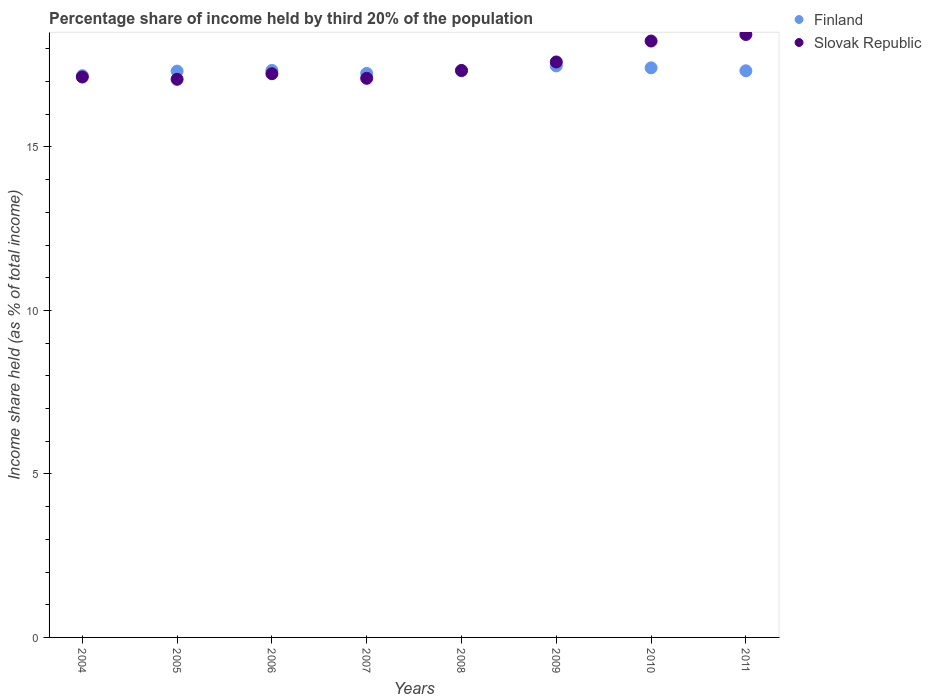Is the number of dotlines equal to the number of legend labels?
Your answer should be very brief. Yes. What is the share of income held by third 20% of the population in Slovak Republic in 2011?
Give a very brief answer. 18.44. Across all years, what is the maximum share of income held by third 20% of the population in Slovak Republic?
Offer a terse response. 18.44. Across all years, what is the minimum share of income held by third 20% of the population in Slovak Republic?
Your answer should be very brief. 17.07. In which year was the share of income held by third 20% of the population in Slovak Republic maximum?
Provide a short and direct response. 2011. What is the total share of income held by third 20% of the population in Finland in the graph?
Give a very brief answer. 138.65. What is the difference between the share of income held by third 20% of the population in Finland in 2005 and that in 2006?
Your answer should be very brief. -0.02. What is the difference between the share of income held by third 20% of the population in Finland in 2011 and the share of income held by third 20% of the population in Slovak Republic in 2007?
Offer a terse response. 0.23. What is the average share of income held by third 20% of the population in Finland per year?
Ensure brevity in your answer.  17.33. In the year 2009, what is the difference between the share of income held by third 20% of the population in Finland and share of income held by third 20% of the population in Slovak Republic?
Provide a short and direct response. -0.12. What is the ratio of the share of income held by third 20% of the population in Finland in 2008 to that in 2009?
Offer a very short reply. 0.99. Is the share of income held by third 20% of the population in Slovak Republic in 2007 less than that in 2010?
Your response must be concise. Yes. Is the difference between the share of income held by third 20% of the population in Finland in 2005 and 2009 greater than the difference between the share of income held by third 20% of the population in Slovak Republic in 2005 and 2009?
Give a very brief answer. Yes. What is the difference between the highest and the second highest share of income held by third 20% of the population in Slovak Republic?
Offer a very short reply. 0.2. What is the difference between the highest and the lowest share of income held by third 20% of the population in Slovak Republic?
Give a very brief answer. 1.37. In how many years, is the share of income held by third 20% of the population in Slovak Republic greater than the average share of income held by third 20% of the population in Slovak Republic taken over all years?
Keep it short and to the point. 3. Is the sum of the share of income held by third 20% of the population in Finland in 2004 and 2006 greater than the maximum share of income held by third 20% of the population in Slovak Republic across all years?
Make the answer very short. Yes. Does the share of income held by third 20% of the population in Slovak Republic monotonically increase over the years?
Keep it short and to the point. No. Is the share of income held by third 20% of the population in Slovak Republic strictly greater than the share of income held by third 20% of the population in Finland over the years?
Offer a very short reply. No. How many years are there in the graph?
Ensure brevity in your answer.  8. Are the values on the major ticks of Y-axis written in scientific E-notation?
Offer a very short reply. No. Does the graph contain grids?
Your answer should be compact. No. How many legend labels are there?
Your answer should be compact. 2. How are the legend labels stacked?
Give a very brief answer. Vertical. What is the title of the graph?
Your response must be concise. Percentage share of income held by third 20% of the population. Does "Sierra Leone" appear as one of the legend labels in the graph?
Keep it short and to the point. No. What is the label or title of the X-axis?
Give a very brief answer. Years. What is the label or title of the Y-axis?
Make the answer very short. Income share held (as % of total income). What is the Income share held (as % of total income) of Finland in 2004?
Offer a very short reply. 17.18. What is the Income share held (as % of total income) in Slovak Republic in 2004?
Give a very brief answer. 17.14. What is the Income share held (as % of total income) of Finland in 2005?
Offer a terse response. 17.32. What is the Income share held (as % of total income) in Slovak Republic in 2005?
Offer a very short reply. 17.07. What is the Income share held (as % of total income) in Finland in 2006?
Keep it short and to the point. 17.34. What is the Income share held (as % of total income) in Slovak Republic in 2006?
Ensure brevity in your answer.  17.24. What is the Income share held (as % of total income) in Finland in 2007?
Provide a short and direct response. 17.25. What is the Income share held (as % of total income) of Slovak Republic in 2007?
Your answer should be very brief. 17.1. What is the Income share held (as % of total income) of Finland in 2008?
Your answer should be compact. 17.33. What is the Income share held (as % of total income) of Slovak Republic in 2008?
Your response must be concise. 17.34. What is the Income share held (as % of total income) of Finland in 2009?
Ensure brevity in your answer.  17.48. What is the Income share held (as % of total income) of Slovak Republic in 2009?
Your answer should be very brief. 17.6. What is the Income share held (as % of total income) in Finland in 2010?
Give a very brief answer. 17.42. What is the Income share held (as % of total income) of Slovak Republic in 2010?
Your response must be concise. 18.24. What is the Income share held (as % of total income) of Finland in 2011?
Make the answer very short. 17.33. What is the Income share held (as % of total income) in Slovak Republic in 2011?
Provide a short and direct response. 18.44. Across all years, what is the maximum Income share held (as % of total income) of Finland?
Provide a succinct answer. 17.48. Across all years, what is the maximum Income share held (as % of total income) of Slovak Republic?
Your answer should be very brief. 18.44. Across all years, what is the minimum Income share held (as % of total income) in Finland?
Keep it short and to the point. 17.18. Across all years, what is the minimum Income share held (as % of total income) in Slovak Republic?
Ensure brevity in your answer.  17.07. What is the total Income share held (as % of total income) of Finland in the graph?
Your answer should be very brief. 138.65. What is the total Income share held (as % of total income) in Slovak Republic in the graph?
Make the answer very short. 140.17. What is the difference between the Income share held (as % of total income) in Finland in 2004 and that in 2005?
Ensure brevity in your answer.  -0.14. What is the difference between the Income share held (as % of total income) in Slovak Republic in 2004 and that in 2005?
Ensure brevity in your answer.  0.07. What is the difference between the Income share held (as % of total income) of Finland in 2004 and that in 2006?
Offer a very short reply. -0.16. What is the difference between the Income share held (as % of total income) in Finland in 2004 and that in 2007?
Provide a short and direct response. -0.07. What is the difference between the Income share held (as % of total income) in Slovak Republic in 2004 and that in 2007?
Your answer should be compact. 0.04. What is the difference between the Income share held (as % of total income) in Slovak Republic in 2004 and that in 2009?
Provide a succinct answer. -0.46. What is the difference between the Income share held (as % of total income) in Finland in 2004 and that in 2010?
Make the answer very short. -0.24. What is the difference between the Income share held (as % of total income) of Finland in 2004 and that in 2011?
Provide a succinct answer. -0.15. What is the difference between the Income share held (as % of total income) in Slovak Republic in 2004 and that in 2011?
Your answer should be very brief. -1.3. What is the difference between the Income share held (as % of total income) of Finland in 2005 and that in 2006?
Your answer should be compact. -0.02. What is the difference between the Income share held (as % of total income) of Slovak Republic in 2005 and that in 2006?
Your answer should be very brief. -0.17. What is the difference between the Income share held (as % of total income) of Finland in 2005 and that in 2007?
Your response must be concise. 0.07. What is the difference between the Income share held (as % of total income) of Slovak Republic in 2005 and that in 2007?
Keep it short and to the point. -0.03. What is the difference between the Income share held (as % of total income) in Finland in 2005 and that in 2008?
Offer a very short reply. -0.01. What is the difference between the Income share held (as % of total income) in Slovak Republic in 2005 and that in 2008?
Your response must be concise. -0.27. What is the difference between the Income share held (as % of total income) of Finland in 2005 and that in 2009?
Ensure brevity in your answer.  -0.16. What is the difference between the Income share held (as % of total income) of Slovak Republic in 2005 and that in 2009?
Provide a succinct answer. -0.53. What is the difference between the Income share held (as % of total income) of Finland in 2005 and that in 2010?
Offer a very short reply. -0.1. What is the difference between the Income share held (as % of total income) of Slovak Republic in 2005 and that in 2010?
Your answer should be compact. -1.17. What is the difference between the Income share held (as % of total income) of Finland in 2005 and that in 2011?
Your answer should be very brief. -0.01. What is the difference between the Income share held (as % of total income) in Slovak Republic in 2005 and that in 2011?
Make the answer very short. -1.37. What is the difference between the Income share held (as % of total income) in Finland in 2006 and that in 2007?
Your answer should be compact. 0.09. What is the difference between the Income share held (as % of total income) of Slovak Republic in 2006 and that in 2007?
Your response must be concise. 0.14. What is the difference between the Income share held (as % of total income) of Finland in 2006 and that in 2009?
Provide a short and direct response. -0.14. What is the difference between the Income share held (as % of total income) of Slovak Republic in 2006 and that in 2009?
Ensure brevity in your answer.  -0.36. What is the difference between the Income share held (as % of total income) of Finland in 2006 and that in 2010?
Make the answer very short. -0.08. What is the difference between the Income share held (as % of total income) of Slovak Republic in 2006 and that in 2010?
Provide a succinct answer. -1. What is the difference between the Income share held (as % of total income) of Finland in 2006 and that in 2011?
Keep it short and to the point. 0.01. What is the difference between the Income share held (as % of total income) in Slovak Republic in 2006 and that in 2011?
Give a very brief answer. -1.2. What is the difference between the Income share held (as % of total income) of Finland in 2007 and that in 2008?
Your answer should be very brief. -0.08. What is the difference between the Income share held (as % of total income) of Slovak Republic in 2007 and that in 2008?
Your response must be concise. -0.24. What is the difference between the Income share held (as % of total income) in Finland in 2007 and that in 2009?
Provide a short and direct response. -0.23. What is the difference between the Income share held (as % of total income) of Slovak Republic in 2007 and that in 2009?
Make the answer very short. -0.5. What is the difference between the Income share held (as % of total income) of Finland in 2007 and that in 2010?
Make the answer very short. -0.17. What is the difference between the Income share held (as % of total income) in Slovak Republic in 2007 and that in 2010?
Make the answer very short. -1.14. What is the difference between the Income share held (as % of total income) of Finland in 2007 and that in 2011?
Your answer should be compact. -0.08. What is the difference between the Income share held (as % of total income) of Slovak Republic in 2007 and that in 2011?
Keep it short and to the point. -1.34. What is the difference between the Income share held (as % of total income) of Finland in 2008 and that in 2009?
Provide a succinct answer. -0.15. What is the difference between the Income share held (as % of total income) in Slovak Republic in 2008 and that in 2009?
Provide a succinct answer. -0.26. What is the difference between the Income share held (as % of total income) of Finland in 2008 and that in 2010?
Offer a terse response. -0.09. What is the difference between the Income share held (as % of total income) of Finland in 2008 and that in 2011?
Provide a succinct answer. 0. What is the difference between the Income share held (as % of total income) of Slovak Republic in 2008 and that in 2011?
Offer a very short reply. -1.1. What is the difference between the Income share held (as % of total income) of Slovak Republic in 2009 and that in 2010?
Offer a terse response. -0.64. What is the difference between the Income share held (as % of total income) in Slovak Republic in 2009 and that in 2011?
Your response must be concise. -0.84. What is the difference between the Income share held (as % of total income) of Finland in 2010 and that in 2011?
Give a very brief answer. 0.09. What is the difference between the Income share held (as % of total income) in Finland in 2004 and the Income share held (as % of total income) in Slovak Republic in 2005?
Give a very brief answer. 0.11. What is the difference between the Income share held (as % of total income) of Finland in 2004 and the Income share held (as % of total income) of Slovak Republic in 2006?
Provide a short and direct response. -0.06. What is the difference between the Income share held (as % of total income) of Finland in 2004 and the Income share held (as % of total income) of Slovak Republic in 2007?
Your answer should be very brief. 0.08. What is the difference between the Income share held (as % of total income) of Finland in 2004 and the Income share held (as % of total income) of Slovak Republic in 2008?
Keep it short and to the point. -0.16. What is the difference between the Income share held (as % of total income) of Finland in 2004 and the Income share held (as % of total income) of Slovak Republic in 2009?
Offer a very short reply. -0.42. What is the difference between the Income share held (as % of total income) of Finland in 2004 and the Income share held (as % of total income) of Slovak Republic in 2010?
Keep it short and to the point. -1.06. What is the difference between the Income share held (as % of total income) in Finland in 2004 and the Income share held (as % of total income) in Slovak Republic in 2011?
Make the answer very short. -1.26. What is the difference between the Income share held (as % of total income) in Finland in 2005 and the Income share held (as % of total income) in Slovak Republic in 2006?
Your answer should be very brief. 0.08. What is the difference between the Income share held (as % of total income) in Finland in 2005 and the Income share held (as % of total income) in Slovak Republic in 2007?
Provide a short and direct response. 0.22. What is the difference between the Income share held (as % of total income) in Finland in 2005 and the Income share held (as % of total income) in Slovak Republic in 2008?
Give a very brief answer. -0.02. What is the difference between the Income share held (as % of total income) in Finland in 2005 and the Income share held (as % of total income) in Slovak Republic in 2009?
Your answer should be compact. -0.28. What is the difference between the Income share held (as % of total income) of Finland in 2005 and the Income share held (as % of total income) of Slovak Republic in 2010?
Make the answer very short. -0.92. What is the difference between the Income share held (as % of total income) of Finland in 2005 and the Income share held (as % of total income) of Slovak Republic in 2011?
Offer a terse response. -1.12. What is the difference between the Income share held (as % of total income) in Finland in 2006 and the Income share held (as % of total income) in Slovak Republic in 2007?
Offer a terse response. 0.24. What is the difference between the Income share held (as % of total income) in Finland in 2006 and the Income share held (as % of total income) in Slovak Republic in 2009?
Your response must be concise. -0.26. What is the difference between the Income share held (as % of total income) in Finland in 2006 and the Income share held (as % of total income) in Slovak Republic in 2010?
Offer a terse response. -0.9. What is the difference between the Income share held (as % of total income) in Finland in 2006 and the Income share held (as % of total income) in Slovak Republic in 2011?
Make the answer very short. -1.1. What is the difference between the Income share held (as % of total income) of Finland in 2007 and the Income share held (as % of total income) of Slovak Republic in 2008?
Your response must be concise. -0.09. What is the difference between the Income share held (as % of total income) in Finland in 2007 and the Income share held (as % of total income) in Slovak Republic in 2009?
Provide a short and direct response. -0.35. What is the difference between the Income share held (as % of total income) of Finland in 2007 and the Income share held (as % of total income) of Slovak Republic in 2010?
Your response must be concise. -0.99. What is the difference between the Income share held (as % of total income) of Finland in 2007 and the Income share held (as % of total income) of Slovak Republic in 2011?
Ensure brevity in your answer.  -1.19. What is the difference between the Income share held (as % of total income) of Finland in 2008 and the Income share held (as % of total income) of Slovak Republic in 2009?
Give a very brief answer. -0.27. What is the difference between the Income share held (as % of total income) in Finland in 2008 and the Income share held (as % of total income) in Slovak Republic in 2010?
Your answer should be very brief. -0.91. What is the difference between the Income share held (as % of total income) in Finland in 2008 and the Income share held (as % of total income) in Slovak Republic in 2011?
Ensure brevity in your answer.  -1.11. What is the difference between the Income share held (as % of total income) of Finland in 2009 and the Income share held (as % of total income) of Slovak Republic in 2010?
Ensure brevity in your answer.  -0.76. What is the difference between the Income share held (as % of total income) of Finland in 2009 and the Income share held (as % of total income) of Slovak Republic in 2011?
Your answer should be compact. -0.96. What is the difference between the Income share held (as % of total income) of Finland in 2010 and the Income share held (as % of total income) of Slovak Republic in 2011?
Your response must be concise. -1.02. What is the average Income share held (as % of total income) of Finland per year?
Your answer should be compact. 17.33. What is the average Income share held (as % of total income) of Slovak Republic per year?
Provide a succinct answer. 17.52. In the year 2005, what is the difference between the Income share held (as % of total income) in Finland and Income share held (as % of total income) in Slovak Republic?
Keep it short and to the point. 0.25. In the year 2007, what is the difference between the Income share held (as % of total income) in Finland and Income share held (as % of total income) in Slovak Republic?
Make the answer very short. 0.15. In the year 2008, what is the difference between the Income share held (as % of total income) in Finland and Income share held (as % of total income) in Slovak Republic?
Offer a terse response. -0.01. In the year 2009, what is the difference between the Income share held (as % of total income) of Finland and Income share held (as % of total income) of Slovak Republic?
Your answer should be very brief. -0.12. In the year 2010, what is the difference between the Income share held (as % of total income) of Finland and Income share held (as % of total income) of Slovak Republic?
Keep it short and to the point. -0.82. In the year 2011, what is the difference between the Income share held (as % of total income) in Finland and Income share held (as % of total income) in Slovak Republic?
Ensure brevity in your answer.  -1.11. What is the ratio of the Income share held (as % of total income) in Slovak Republic in 2004 to that in 2005?
Give a very brief answer. 1. What is the ratio of the Income share held (as % of total income) in Finland in 2004 to that in 2007?
Give a very brief answer. 1. What is the ratio of the Income share held (as % of total income) in Slovak Republic in 2004 to that in 2007?
Your answer should be compact. 1. What is the ratio of the Income share held (as % of total income) of Finland in 2004 to that in 2008?
Give a very brief answer. 0.99. What is the ratio of the Income share held (as % of total income) in Finland in 2004 to that in 2009?
Make the answer very short. 0.98. What is the ratio of the Income share held (as % of total income) in Slovak Republic in 2004 to that in 2009?
Keep it short and to the point. 0.97. What is the ratio of the Income share held (as % of total income) in Finland in 2004 to that in 2010?
Keep it short and to the point. 0.99. What is the ratio of the Income share held (as % of total income) in Slovak Republic in 2004 to that in 2010?
Provide a short and direct response. 0.94. What is the ratio of the Income share held (as % of total income) in Slovak Republic in 2004 to that in 2011?
Provide a short and direct response. 0.93. What is the ratio of the Income share held (as % of total income) in Finland in 2005 to that in 2006?
Make the answer very short. 1. What is the ratio of the Income share held (as % of total income) in Slovak Republic in 2005 to that in 2006?
Provide a short and direct response. 0.99. What is the ratio of the Income share held (as % of total income) in Finland in 2005 to that in 2007?
Ensure brevity in your answer.  1. What is the ratio of the Income share held (as % of total income) of Slovak Republic in 2005 to that in 2008?
Your answer should be compact. 0.98. What is the ratio of the Income share held (as % of total income) of Slovak Republic in 2005 to that in 2009?
Ensure brevity in your answer.  0.97. What is the ratio of the Income share held (as % of total income) in Slovak Republic in 2005 to that in 2010?
Keep it short and to the point. 0.94. What is the ratio of the Income share held (as % of total income) in Finland in 2005 to that in 2011?
Ensure brevity in your answer.  1. What is the ratio of the Income share held (as % of total income) in Slovak Republic in 2005 to that in 2011?
Offer a terse response. 0.93. What is the ratio of the Income share held (as % of total income) of Slovak Republic in 2006 to that in 2007?
Provide a short and direct response. 1.01. What is the ratio of the Income share held (as % of total income) in Slovak Republic in 2006 to that in 2009?
Your response must be concise. 0.98. What is the ratio of the Income share held (as % of total income) in Slovak Republic in 2006 to that in 2010?
Make the answer very short. 0.95. What is the ratio of the Income share held (as % of total income) of Finland in 2006 to that in 2011?
Keep it short and to the point. 1. What is the ratio of the Income share held (as % of total income) of Slovak Republic in 2006 to that in 2011?
Your answer should be very brief. 0.93. What is the ratio of the Income share held (as % of total income) of Slovak Republic in 2007 to that in 2008?
Offer a very short reply. 0.99. What is the ratio of the Income share held (as % of total income) of Finland in 2007 to that in 2009?
Offer a terse response. 0.99. What is the ratio of the Income share held (as % of total income) of Slovak Republic in 2007 to that in 2009?
Ensure brevity in your answer.  0.97. What is the ratio of the Income share held (as % of total income) in Finland in 2007 to that in 2010?
Offer a very short reply. 0.99. What is the ratio of the Income share held (as % of total income) in Finland in 2007 to that in 2011?
Ensure brevity in your answer.  1. What is the ratio of the Income share held (as % of total income) of Slovak Republic in 2007 to that in 2011?
Provide a short and direct response. 0.93. What is the ratio of the Income share held (as % of total income) in Slovak Republic in 2008 to that in 2009?
Make the answer very short. 0.99. What is the ratio of the Income share held (as % of total income) of Finland in 2008 to that in 2010?
Keep it short and to the point. 0.99. What is the ratio of the Income share held (as % of total income) of Slovak Republic in 2008 to that in 2010?
Your answer should be very brief. 0.95. What is the ratio of the Income share held (as % of total income) in Finland in 2008 to that in 2011?
Ensure brevity in your answer.  1. What is the ratio of the Income share held (as % of total income) of Slovak Republic in 2008 to that in 2011?
Provide a succinct answer. 0.94. What is the ratio of the Income share held (as % of total income) in Slovak Republic in 2009 to that in 2010?
Ensure brevity in your answer.  0.96. What is the ratio of the Income share held (as % of total income) of Finland in 2009 to that in 2011?
Offer a terse response. 1.01. What is the ratio of the Income share held (as % of total income) of Slovak Republic in 2009 to that in 2011?
Provide a short and direct response. 0.95. What is the ratio of the Income share held (as % of total income) of Finland in 2010 to that in 2011?
Your answer should be compact. 1.01. What is the difference between the highest and the second highest Income share held (as % of total income) in Finland?
Keep it short and to the point. 0.06. What is the difference between the highest and the lowest Income share held (as % of total income) of Slovak Republic?
Your answer should be compact. 1.37. 